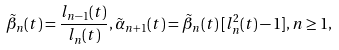Convert formula to latex. <formula><loc_0><loc_0><loc_500><loc_500>\tilde { \beta } _ { n } ( t ) = \frac { l _ { n - 1 } ( t ) } { l _ { n } ( t ) } , \tilde { \alpha } _ { n + 1 } ( t ) = \tilde { \beta } _ { n } ( t ) \, [ l _ { n } ^ { 2 } ( t ) - 1 ] , n \geq 1 ,</formula> 